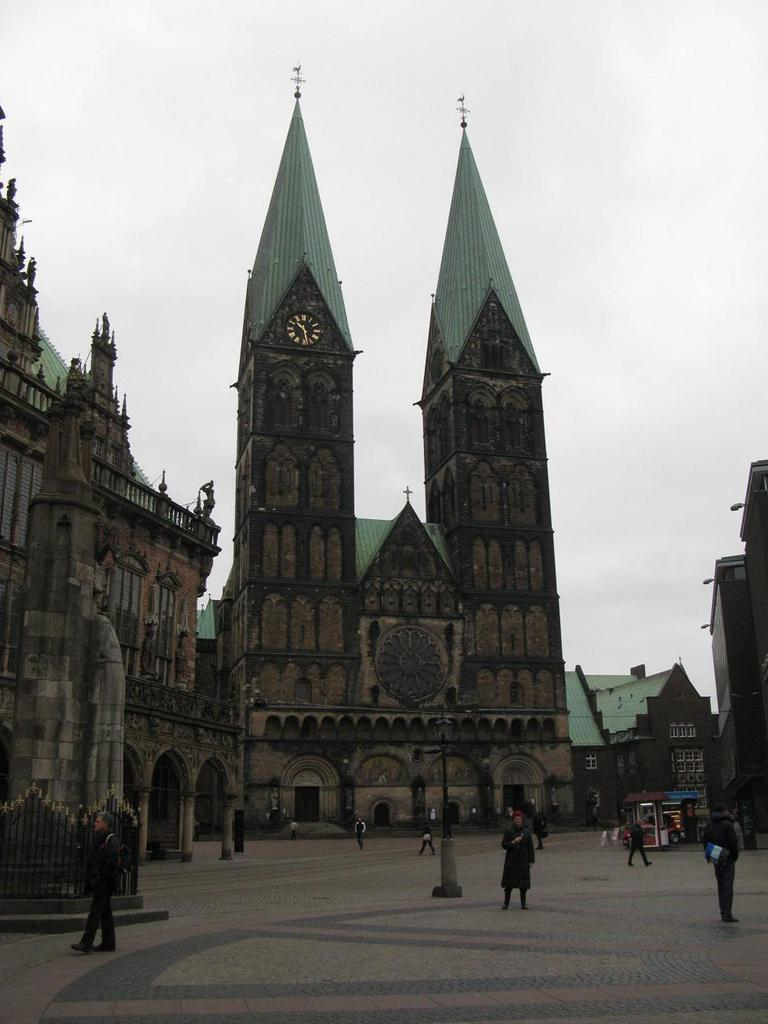What is happening on the road in the image? There are people on the road in the image. What else can be seen on the road besides people? There are vehicles in the image. What type of barrier is present along the road? There is metal railing in the image. What structures are visible in the image? There are buildings in the image. What can be seen in the distance in the image? The sky is visible in the background of the image. What is the cause of the engine's malfunction in the image? There is no engine present in the image, so it is not possible to determine the cause of any malfunction. 